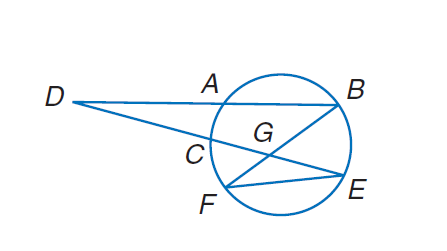Answer the mathemtical geometry problem and directly provide the correct option letter.
Question: Find m \widehat E D B if m \widehat F E = 118, m \widehat A B = 108, m \angle E G B = 52, and m \angle E F B = 30.
Choices: A: 15 B: 52 C: 108 D: 118 A 